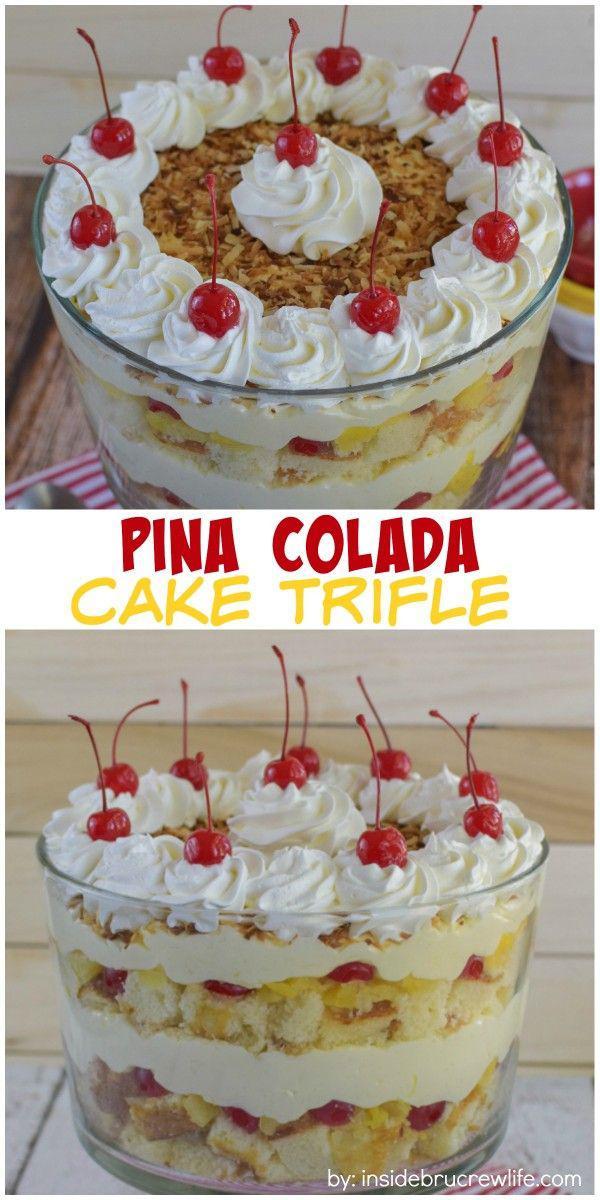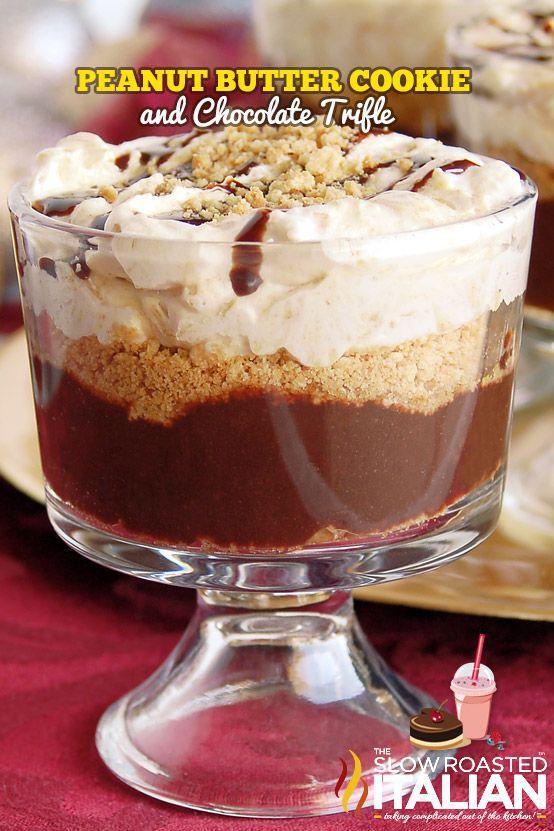The first image is the image on the left, the second image is the image on the right. Analyze the images presented: Is the assertion "The image on the left shows a single bowl of trifle while the image on the right shows two pedestal bowls of trifle." valid? Answer yes or no. No. The first image is the image on the left, the second image is the image on the right. Assess this claim about the two images: "cream layered desserts with at least 1 cherry on top". Correct or not? Answer yes or no. Yes. 